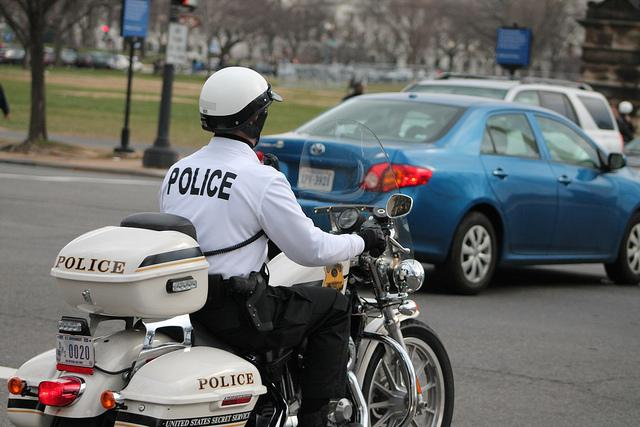The Harley police bikes are iconic bikes of police force in? Please explain your reasoning. us. The text before secret service on the side of the bike indicates the country where these bikes are used. 